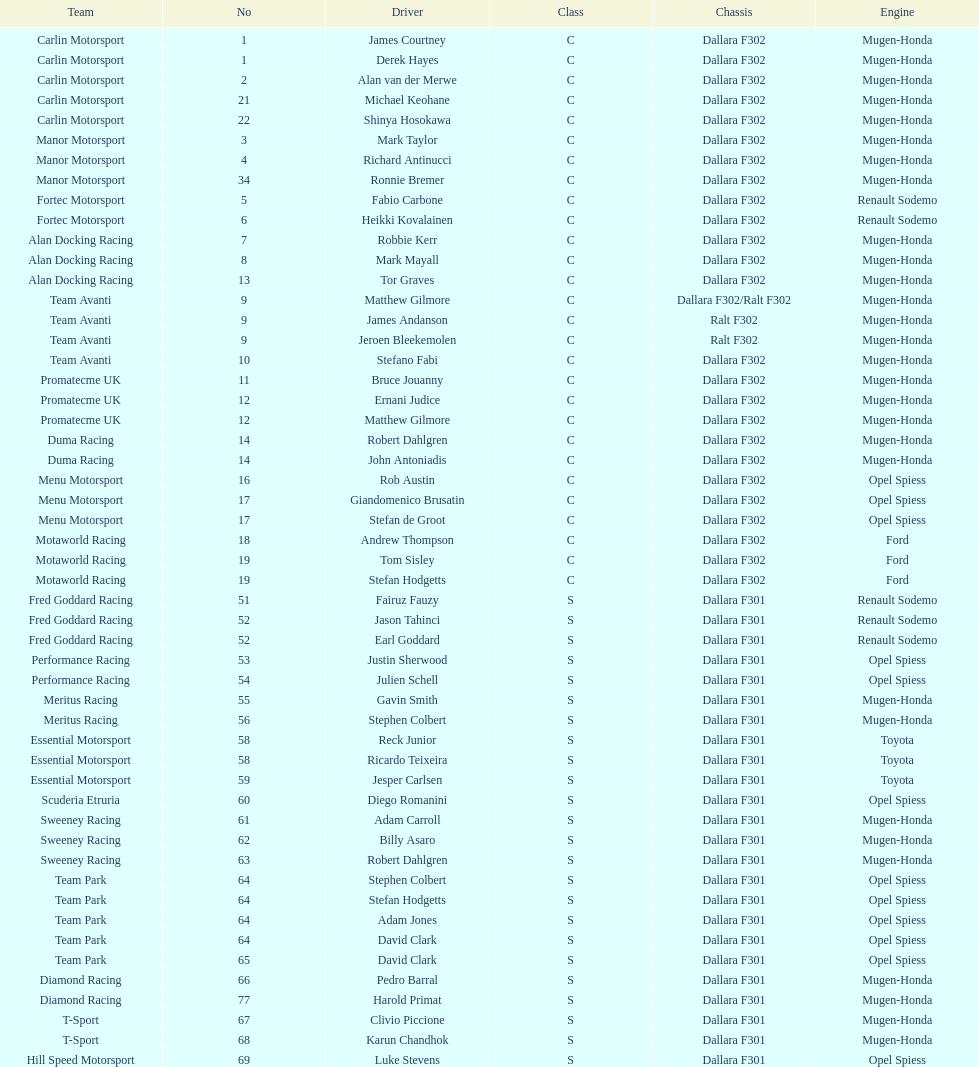On the chart, how many teams are classified under class s (scholarship)? 19. 